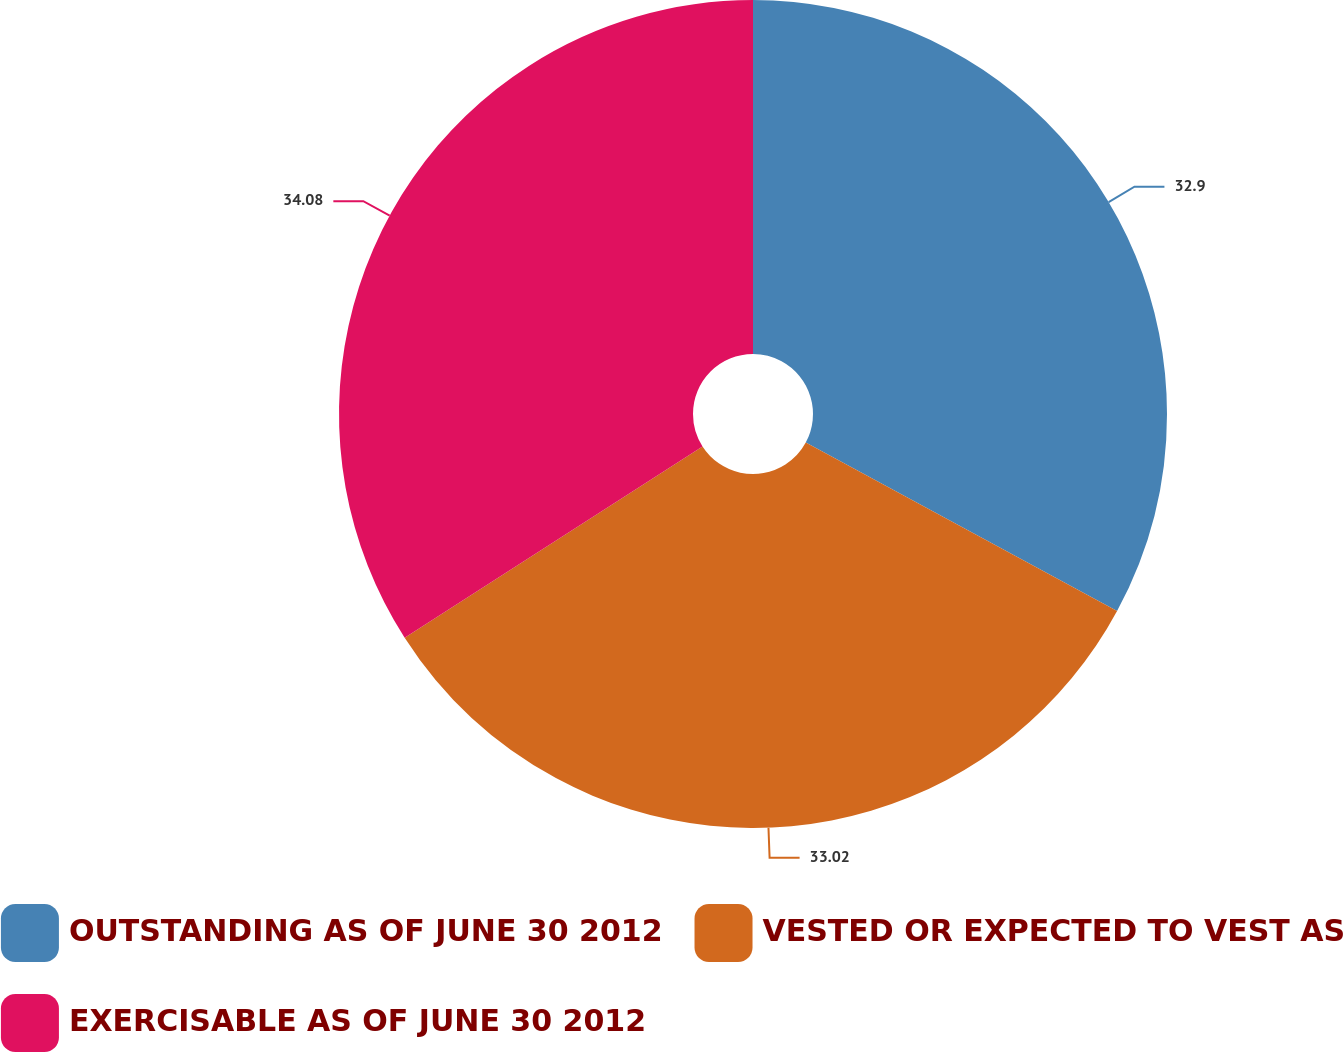<chart> <loc_0><loc_0><loc_500><loc_500><pie_chart><fcel>OUTSTANDING AS OF JUNE 30 2012<fcel>VESTED OR EXPECTED TO VEST AS<fcel>EXERCISABLE AS OF JUNE 30 2012<nl><fcel>32.9%<fcel>33.02%<fcel>34.09%<nl></chart> 